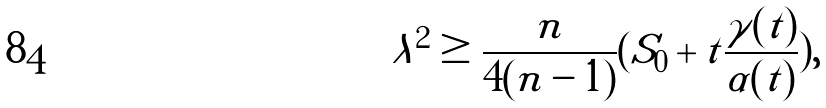Convert formula to latex. <formula><loc_0><loc_0><loc_500><loc_500>\lambda ^ { 2 } \geq \frac { n } { 4 ( n - 1 ) } ( S _ { 0 } + t \frac { \gamma ( t ) } { \alpha ( t ) } ) ,</formula> 